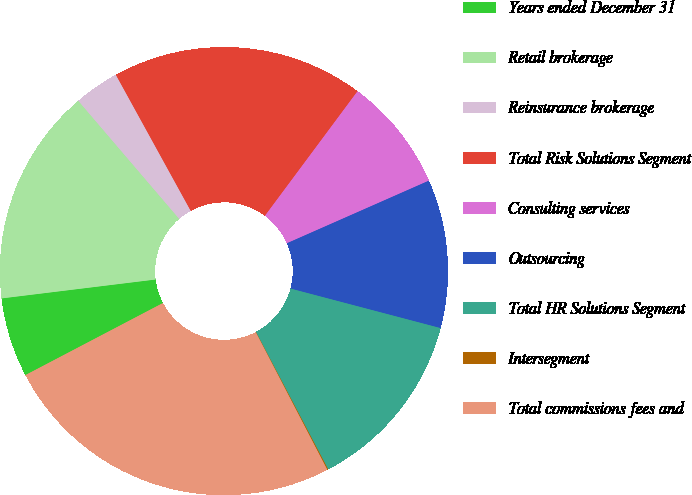Convert chart. <chart><loc_0><loc_0><loc_500><loc_500><pie_chart><fcel>Years ended December 31<fcel>Retail brokerage<fcel>Reinsurance brokerage<fcel>Total Risk Solutions Segment<fcel>Consulting services<fcel>Outsourcing<fcel>Total HR Solutions Segment<fcel>Intersegment<fcel>Total commissions fees and<nl><fcel>5.74%<fcel>15.69%<fcel>3.25%<fcel>18.18%<fcel>8.22%<fcel>10.71%<fcel>13.2%<fcel>0.07%<fcel>24.95%<nl></chart> 